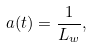<formula> <loc_0><loc_0><loc_500><loc_500>a ( t ) = \frac { 1 } { L _ { w } } ,</formula> 